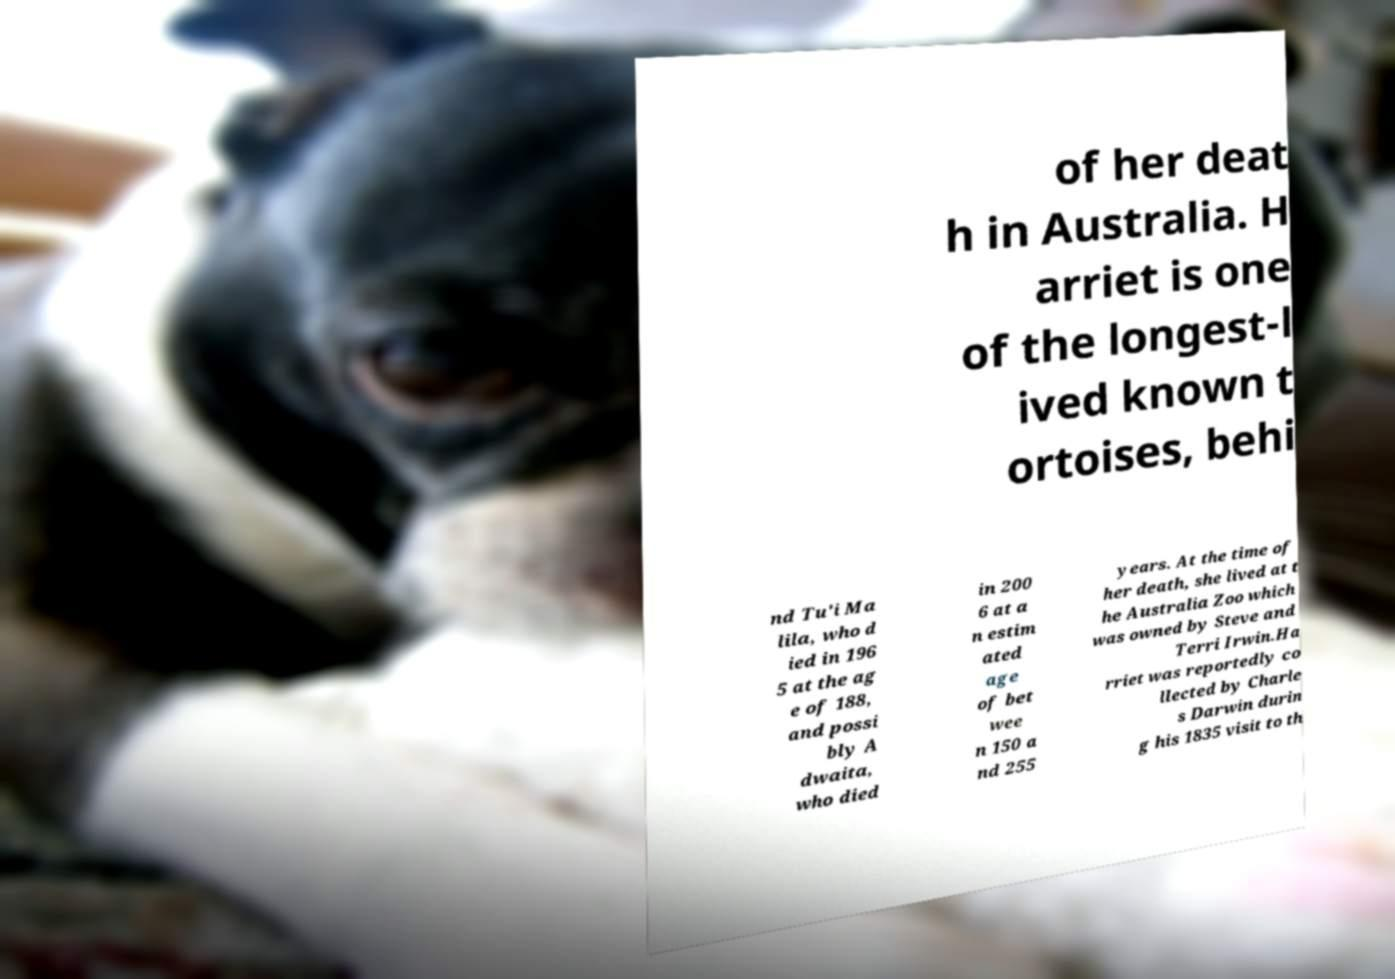Please identify and transcribe the text found in this image. of her deat h in Australia. H arriet is one of the longest-l ived known t ortoises, behi nd Tu'i Ma lila, who d ied in 196 5 at the ag e of 188, and possi bly A dwaita, who died in 200 6 at a n estim ated age of bet wee n 150 a nd 255 years. At the time of her death, she lived at t he Australia Zoo which was owned by Steve and Terri Irwin.Ha rriet was reportedly co llected by Charle s Darwin durin g his 1835 visit to th 